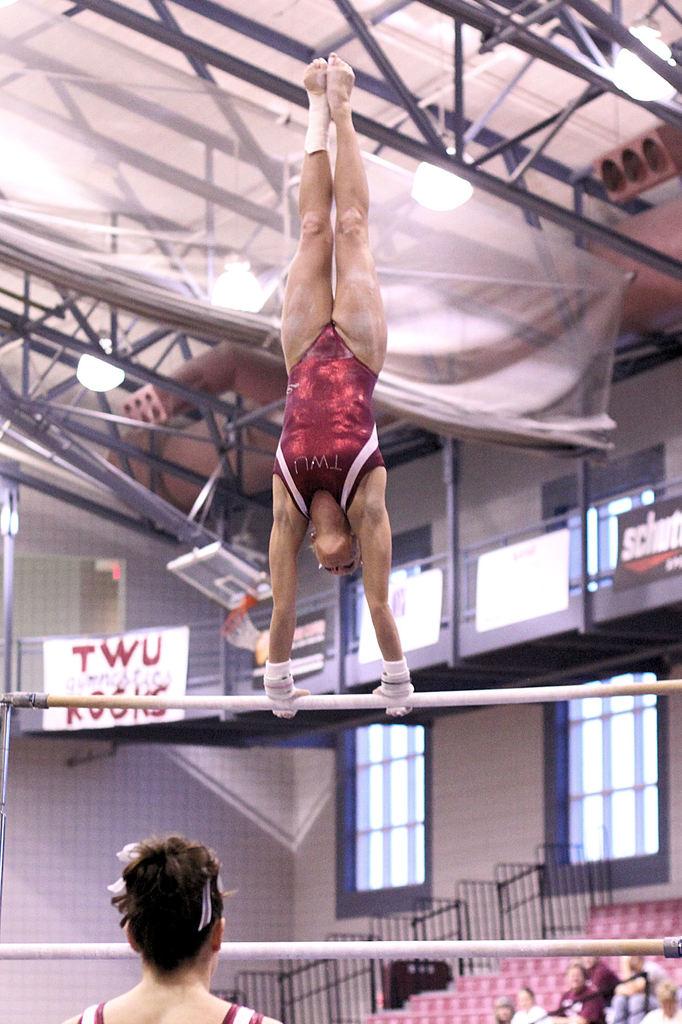What university is this gymnast a part of?
Provide a short and direct response. Twu. 